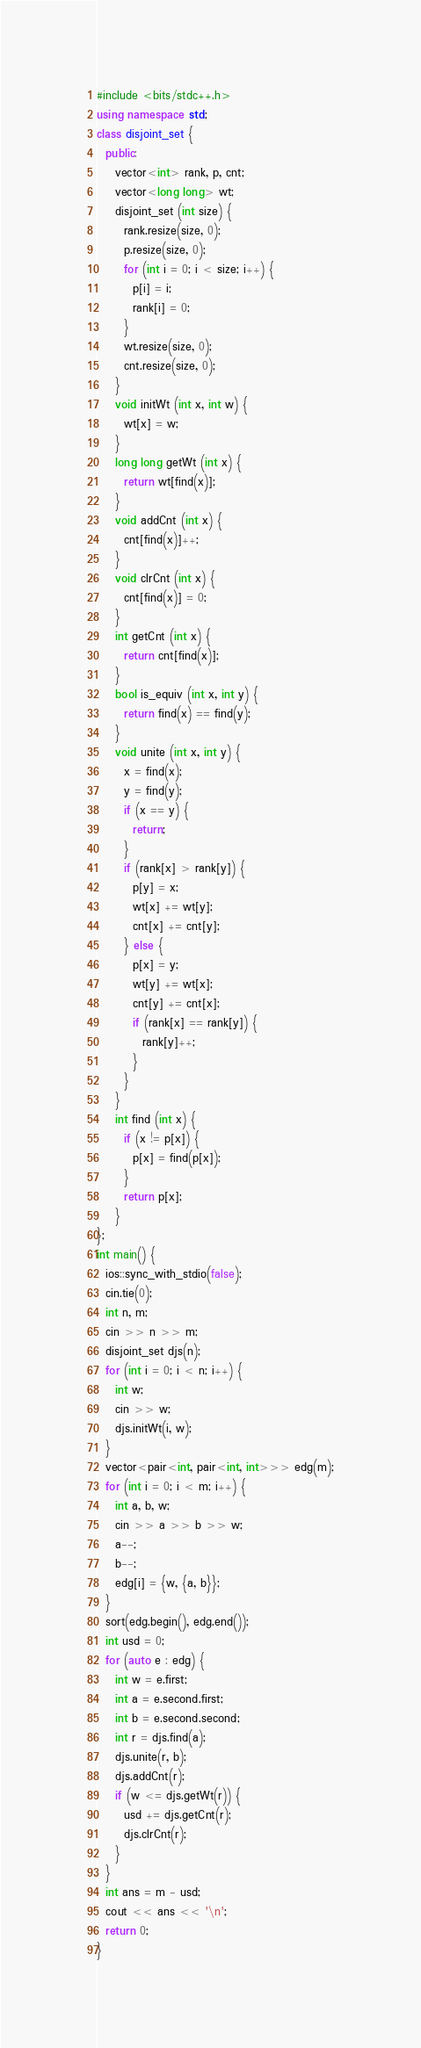<code> <loc_0><loc_0><loc_500><loc_500><_C++_>#include <bits/stdc++.h>
using namespace std;
class disjoint_set {
  public:
    vector<int> rank, p, cnt;
    vector<long long> wt;
    disjoint_set (int size) {
      rank.resize(size, 0);
      p.resize(size, 0);
      for (int i = 0; i < size; i++) {
        p[i] = i;
        rank[i] = 0;
      }
      wt.resize(size, 0);
      cnt.resize(size, 0);
    }
    void initWt (int x, int w) {
      wt[x] = w;
    }
    long long getWt (int x) {
      return wt[find(x)];
    }
    void addCnt (int x) {
      cnt[find(x)]++;
    }
    void clrCnt (int x) {
      cnt[find(x)] = 0;
    }
    int getCnt (int x) {
      return cnt[find(x)];
    }
    bool is_equiv (int x, int y) {
      return find(x) == find(y);
    }
    void unite (int x, int y) {
      x = find(x);
      y = find(y);
      if (x == y) {
        return;
      }
      if (rank[x] > rank[y]) {
        p[y] = x;
        wt[x] += wt[y];
        cnt[x] += cnt[y];
      } else {
        p[x] = y;
        wt[y] += wt[x];
        cnt[y] += cnt[x];
        if (rank[x] == rank[y]) {
          rank[y]++;
        }
      }
    }
    int find (int x) {
      if (x != p[x]) {
        p[x] = find(p[x]);
      }
      return p[x];
    }
};
int main() {
  ios::sync_with_stdio(false);
  cin.tie(0);
  int n, m;
  cin >> n >> m;
  disjoint_set djs(n);
  for (int i = 0; i < n; i++) {
    int w;
    cin >> w;
    djs.initWt(i, w);
  }
  vector<pair<int, pair<int, int>>> edg(m);
  for (int i = 0; i < m; i++) {
    int a, b, w;
    cin >> a >> b >> w;
    a--;
    b--;
    edg[i] = {w, {a, b}};
  }
  sort(edg.begin(), edg.end());
  int usd = 0;
  for (auto e : edg) {
    int w = e.first;
    int a = e.second.first;
    int b = e.second.second;
    int r = djs.find(a);
    djs.unite(r, b);
    djs.addCnt(r);
    if (w <= djs.getWt(r)) {
      usd += djs.getCnt(r);
      djs.clrCnt(r);
    }
  }
  int ans = m - usd;
  cout << ans << '\n';
  return 0;
}</code> 